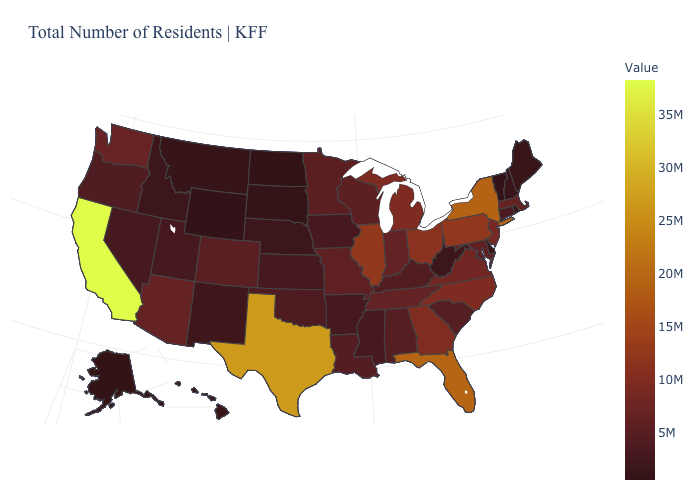Is the legend a continuous bar?
Be succinct. Yes. Which states have the lowest value in the MidWest?
Write a very short answer. North Dakota. Which states hav the highest value in the West?
Quick response, please. California. Does Colorado have a higher value than Illinois?
Give a very brief answer. No. 